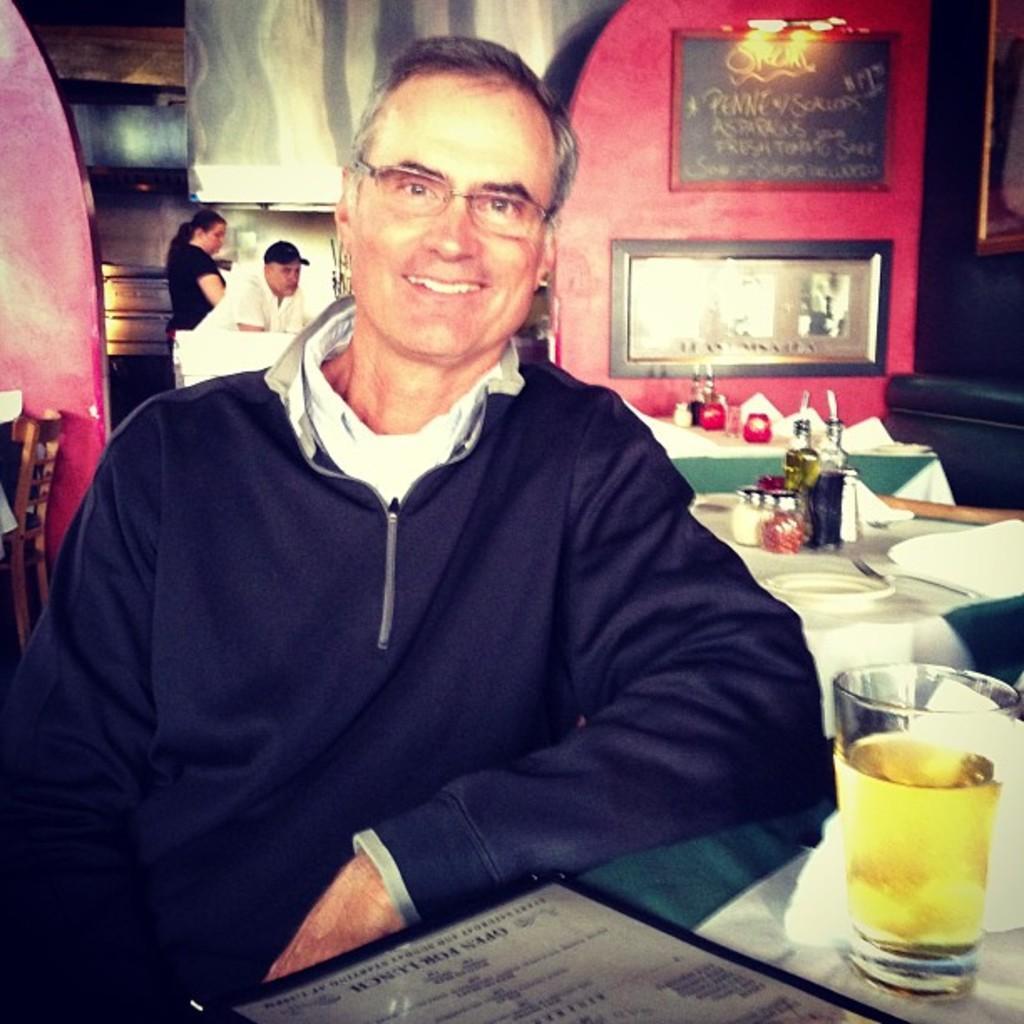Can you describe this image briefly? In this picture we can see a man. He is smiling and he has spectacles. This is table. On the table there are glasses, plate, and a bottle. On the background we can see two persons. This is wall and there are frames. 